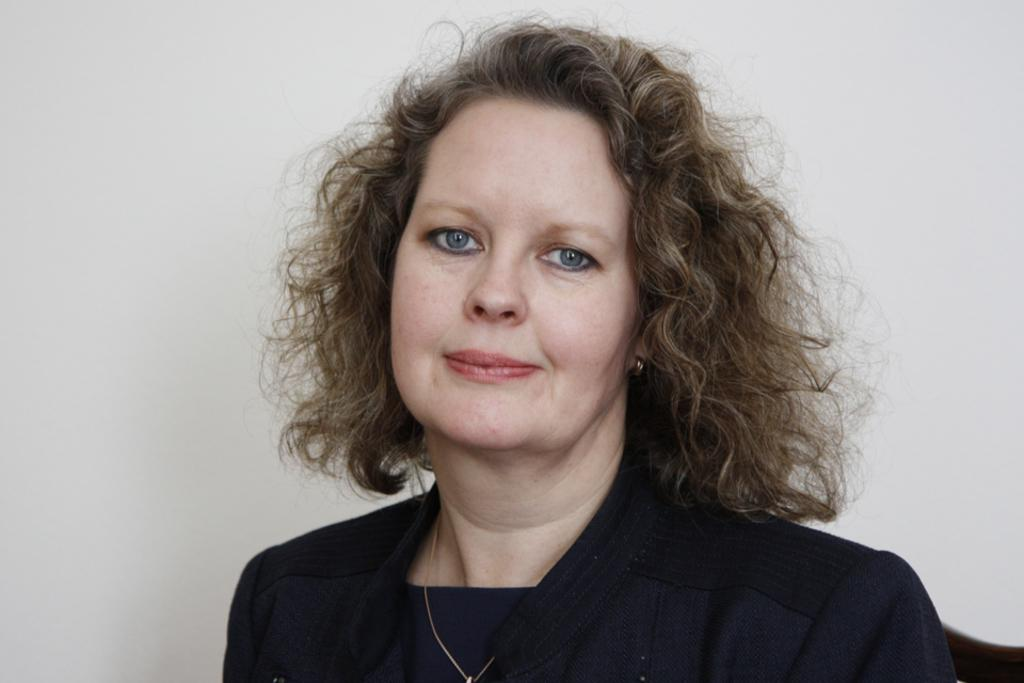Who is present in the image? There is a woman in the image. What is the woman's facial expression? The woman is smiling. What can be seen in the background of the image? The background of the image features a plane. What type of crime is being committed in the image? There is no crime being committed in the image; it features a woman smiling with a plane in the background. What unit of measurement is the robin using to determine the distance in the image? There is no robin present in the image, and therefore no unit of measurement can be determined. 